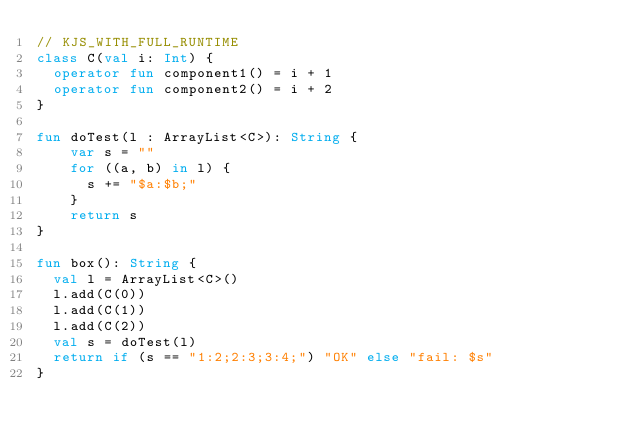Convert code to text. <code><loc_0><loc_0><loc_500><loc_500><_Kotlin_>// KJS_WITH_FULL_RUNTIME
class C(val i: Int) {
  operator fun component1() = i + 1
  operator fun component2() = i + 2
}

fun doTest(l : ArrayList<C>): String {
    var s = ""
    for ((a, b) in l) {
      s += "$a:$b;"
    }
    return s
}

fun box(): String {
  val l = ArrayList<C>()
  l.add(C(0))
  l.add(C(1))
  l.add(C(2))
  val s = doTest(l)
  return if (s == "1:2;2:3;3:4;") "OK" else "fail: $s"
}</code> 